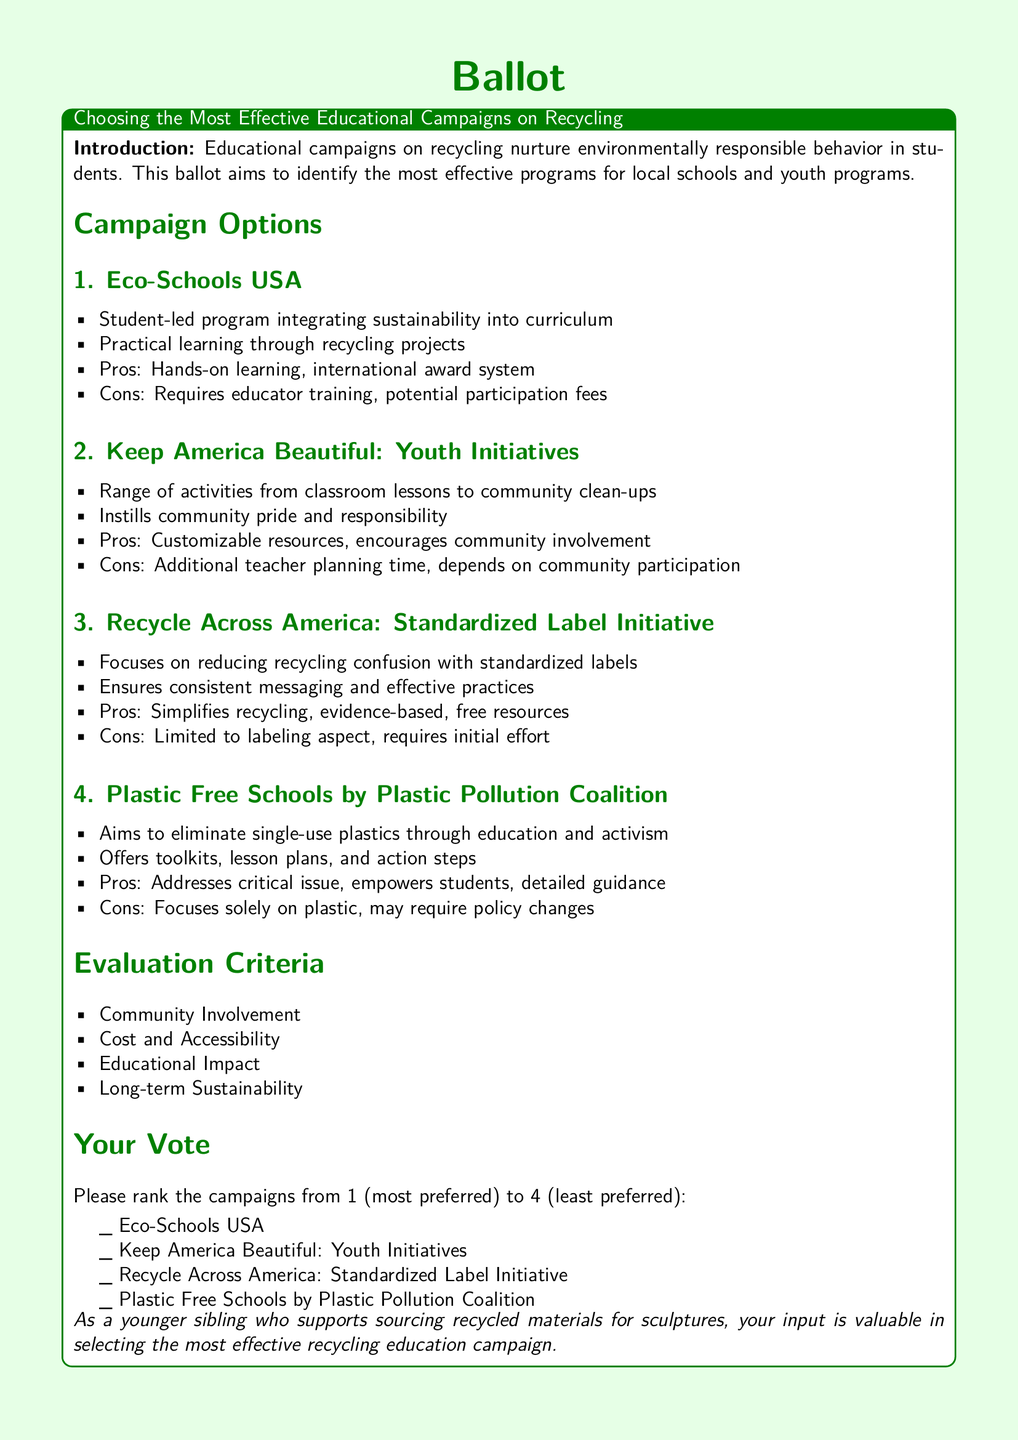What is the title of the ballot? The title of the ballot is stated at the top of the document in a large font size.
Answer: Choosing the Most Effective Educational Campaigns on Recycling List one campaign under the "Campaign Options" section. The document lists four campaigns under the "Campaign Options," and each is described briefly.
Answer: Eco-Schools USA What is one pro of the "Recycle Across America" campaign? The pros for each campaign are listed, and one is specifically mentioned for the Recycle Across America initiative.
Answer: Simplifies recycling How many evaluation criteria are listed in the document? The document includes a section titled "Evaluation Criteria," which lists the criteria.
Answer: Four Which campaign addresses the issue of single-use plastics? The document mentions this specific campaign focusing on plastics under the "Campaign Options" section.
Answer: Plastic Free Schools by Plastic Pollution Coalition What is the ranking system used for votes? The document specifies how voters should rank the campaigns in their vote.
Answer: 1 to 4 State one con of the "Keep America Beautiful" campaign. The cons for each campaign are listed, and one specific con is included for this initiative.
Answer: Additional teacher planning time What type of educational approach does Eco-Schools USA utilize? The document describes the approach of Eco-Schools USA in the context of educational campaigns.
Answer: Student-led program Which campaign offers free resources? The document specifies that this campaign provides certain resources at no cost.
Answer: Recycle Across America 